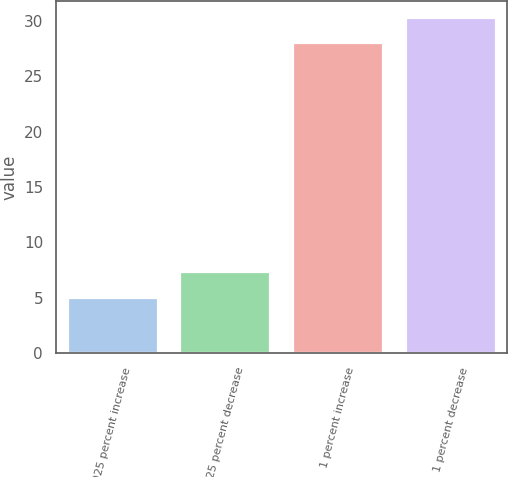Convert chart. <chart><loc_0><loc_0><loc_500><loc_500><bar_chart><fcel>025 percent increase<fcel>025 percent decrease<fcel>1 percent increase<fcel>1 percent decrease<nl><fcel>5<fcel>7.3<fcel>28<fcel>30.3<nl></chart> 